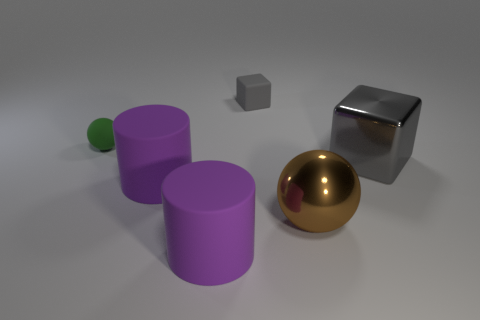Add 3 metal objects. How many objects exist? 9 Subtract all balls. How many objects are left? 4 Subtract all small purple shiny cubes. Subtract all tiny green objects. How many objects are left? 5 Add 6 purple cylinders. How many purple cylinders are left? 8 Add 2 small rubber cubes. How many small rubber cubes exist? 3 Subtract 0 blue cubes. How many objects are left? 6 